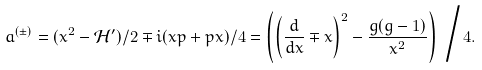<formula> <loc_0><loc_0><loc_500><loc_500>a ^ { ( \pm ) } = ( x ^ { 2 } - \mathcal { H } ^ { \prime } ) / 2 \mp i ( x p + p x ) / 4 = \left ( \left ( \frac { d } { d x } \mp x \right ) ^ { 2 } - \frac { g ( g - 1 ) } { x ^ { 2 } } \right ) \, \Big / 4 .</formula> 